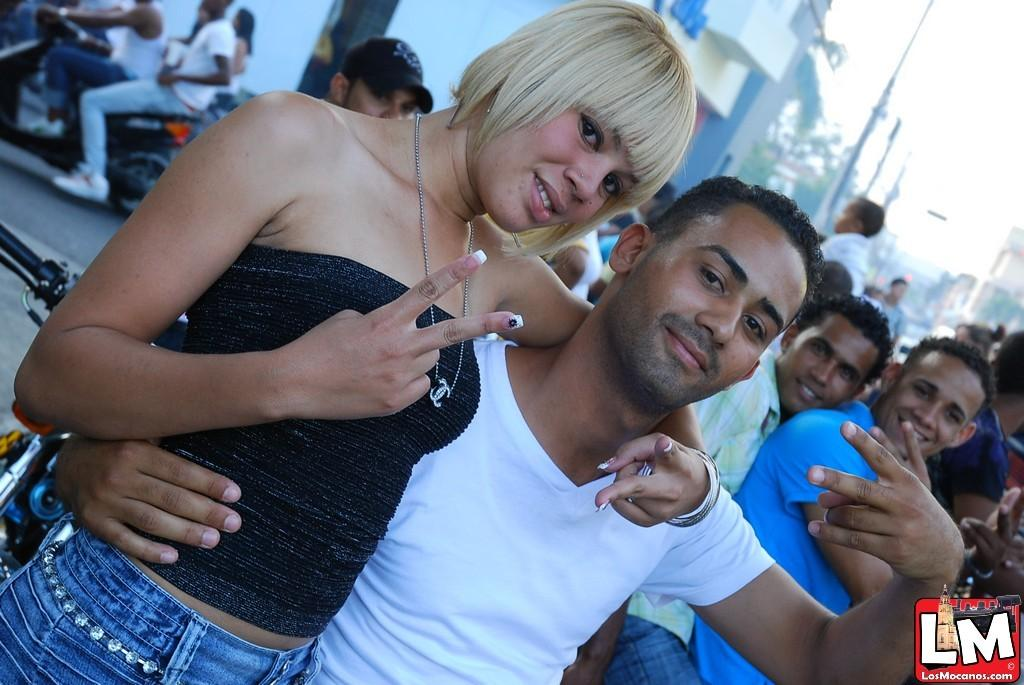How many people are in the group that is visible in the image? There is a group of people in the image, but the exact number is not specified. What is the person wearing in the group? One person in the group is wearing a black and blue dress. What can be seen in the background of the image? There are poles and buildings in the background of the image. What is the color of the sky in the image? The sky is visible in the image, and it appears to be white in color. How many birds are sitting on the pen in the image? There are no birds or pens present in the image. What type of basket is being used by the person in the black and blue dress? There is no basket visible in the image, and the person in the black and blue dress is not holding or using any basket. 